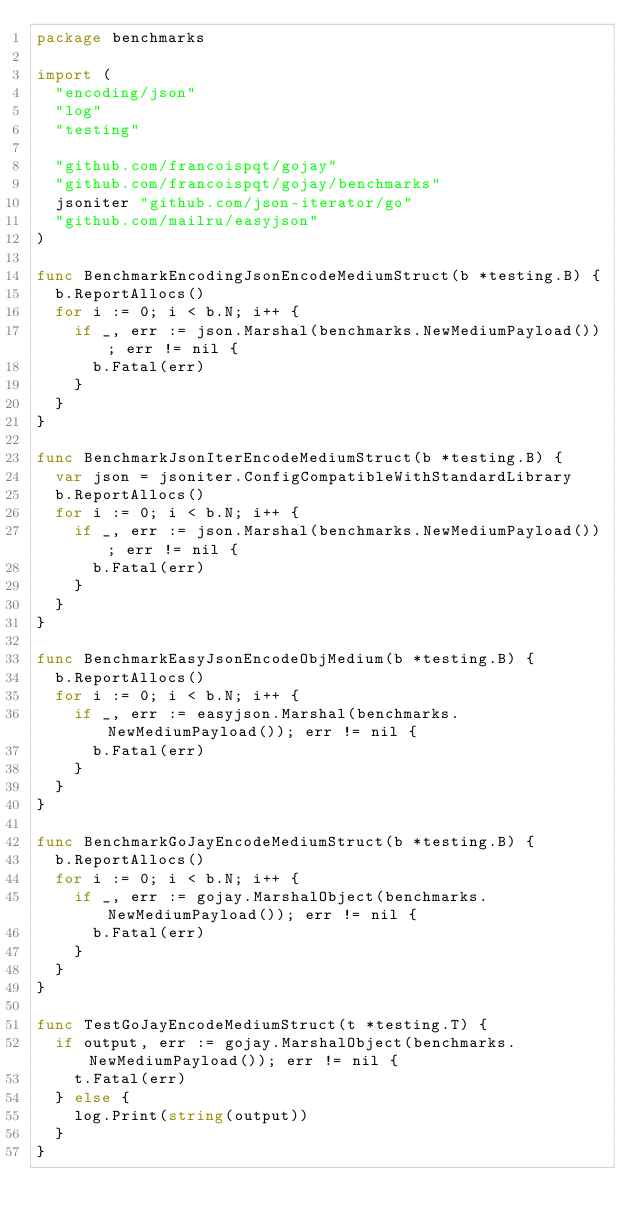<code> <loc_0><loc_0><loc_500><loc_500><_Go_>package benchmarks

import (
	"encoding/json"
	"log"
	"testing"

	"github.com/francoispqt/gojay"
	"github.com/francoispqt/gojay/benchmarks"
	jsoniter "github.com/json-iterator/go"
	"github.com/mailru/easyjson"
)

func BenchmarkEncodingJsonEncodeMediumStruct(b *testing.B) {
	b.ReportAllocs()
	for i := 0; i < b.N; i++ {
		if _, err := json.Marshal(benchmarks.NewMediumPayload()); err != nil {
			b.Fatal(err)
		}
	}
}

func BenchmarkJsonIterEncodeMediumStruct(b *testing.B) {
	var json = jsoniter.ConfigCompatibleWithStandardLibrary
	b.ReportAllocs()
	for i := 0; i < b.N; i++ {
		if _, err := json.Marshal(benchmarks.NewMediumPayload()); err != nil {
			b.Fatal(err)
		}
	}
}

func BenchmarkEasyJsonEncodeObjMedium(b *testing.B) {
	b.ReportAllocs()
	for i := 0; i < b.N; i++ {
		if _, err := easyjson.Marshal(benchmarks.NewMediumPayload()); err != nil {
			b.Fatal(err)
		}
	}
}

func BenchmarkGoJayEncodeMediumStruct(b *testing.B) {
	b.ReportAllocs()
	for i := 0; i < b.N; i++ {
		if _, err := gojay.MarshalObject(benchmarks.NewMediumPayload()); err != nil {
			b.Fatal(err)
		}
	}
}

func TestGoJayEncodeMediumStruct(t *testing.T) {
	if output, err := gojay.MarshalObject(benchmarks.NewMediumPayload()); err != nil {
		t.Fatal(err)
	} else {
		log.Print(string(output))
	}
}
</code> 